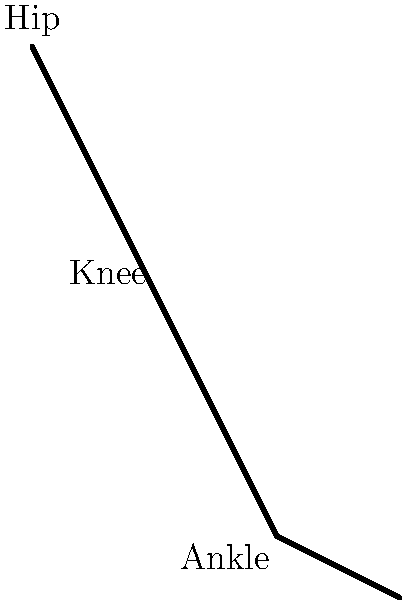When climbing steep steps in historical buildings, which muscle group is primarily responsible for extending the knee joint and what is the typical range of motion for the knee angle ($\theta$) during this action? To answer this question, let's break down the biomechanics of climbing steep steps:

1. Muscle group responsible for knee extension:
   The primary muscle group responsible for extending the knee joint is the quadriceps femoris. This group consists of four muscles:
   a) Rectus femoris
   b) Vastus lateralis
   c) Vastus medialis
   d) Vastus intermedius

2. Action of the quadriceps during step climbing:
   When climbing steep steps, the quadriceps contract concentrically to extend the knee joint, pushing the body upward against gravity.

3. Knee angle (θ) range of motion:
   The typical range of motion for the knee angle during stair climbing varies depending on the steepness of the steps and individual factors. However, general ranges are:
   a) Starting position (foot on lower step): θ ≈ 70-90 degrees
   b) Ending position (leg extended): θ ≈ 10-30 degrees

4. Total range of motion:
   The total range of motion for the knee angle during step climbing is typically between 40-80 degrees.

5. Other muscle groups involved:
   While the quadriceps are primary for knee extension, other muscle groups also play important roles:
   a) Hamstrings: Assist in hip extension and knee flexion control
   b) Calf muscles (gastrocnemius and soleus): Plantar flexion of the ankle

6. Joint angles:
   The knee angle (θ) works in conjunction with the ankle angle (φ) to provide the necessary leverage for climbing steep steps.

In the context of historical buildings, steep and narrow steps are common, which may require a greater range of motion and more muscle activation compared to modern staircases.
Answer: Quadriceps; 40-80 degrees 